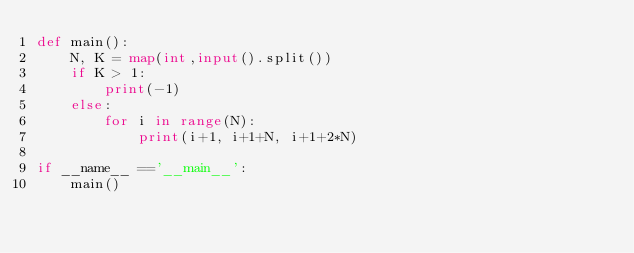Convert code to text. <code><loc_0><loc_0><loc_500><loc_500><_Python_>def main():
    N, K = map(int,input().split())
    if K > 1:
        print(-1)
    else:
        for i in range(N):
            print(i+1, i+1+N, i+1+2*N)

if __name__ =='__main__':
    main()</code> 